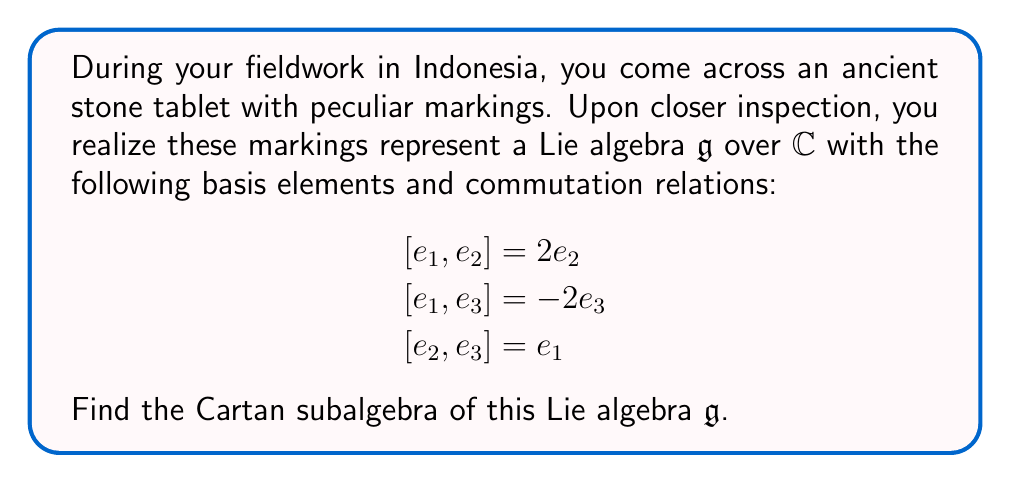Solve this math problem. To find the Cartan subalgebra of the given Lie algebra $\mathfrak{g}$, we follow these steps:

1) Recall that a Cartan subalgebra is a maximal abelian subalgebra consisting of semisimple elements.

2) We need to find a maximal set of elements that commute with each other and are diagonalizable.

3) Let's consider the general element $x = ae_1 + be_2 + ce_3$ where $a,b,c \in \mathbb{C}$.

4) We compute the adjoint action of $x$ on the basis elements:

   $$\begin{aligned}
   [x, e_1] &= [ae_1 + be_2 + ce_3, e_1] = 2be_2 - 2ce_3 \\
   [x, e_2] &= [ae_1 + be_2 + ce_3, e_2] = -2ae_2 + ce_1 \\
   [x, e_3] &= [ae_1 + be_2 + ce_3, e_3] = 2ae_3 - be_1
   \end{aligned}$$

5) For $x$ to be in the Cartan subalgebra, it must commute with itself. This means $[x, e_1] = [x, e_2] = [x, e_3] = 0$.

6) From $[x, e_1] = 0$, we get $b = c = 0$.

7) With $b = c = 0$, the other conditions $[x, e_2] = [x, e_3] = 0$ are automatically satisfied.

8) Therefore, the Cartan subalgebra consists of elements of the form $ae_1$ where $a \in \mathbb{C}$.

9) We can verify that this is indeed a maximal abelian subalgebra consisting of semisimple elements.

Thus, the Cartan subalgebra of $\mathfrak{g}$ is the one-dimensional subspace spanned by $e_1$.
Answer: $\text{span}\{e_1\}$ 